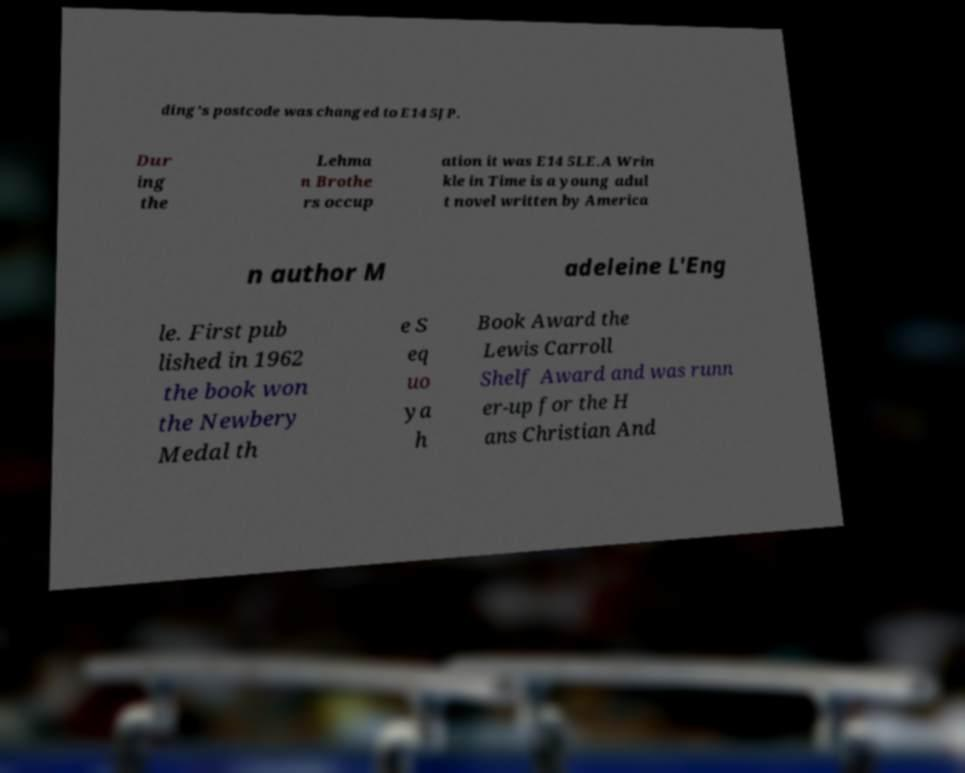Can you read and provide the text displayed in the image?This photo seems to have some interesting text. Can you extract and type it out for me? ding's postcode was changed to E14 5JP. Dur ing the Lehma n Brothe rs occup ation it was E14 5LE.A Wrin kle in Time is a young adul t novel written by America n author M adeleine L'Eng le. First pub lished in 1962 the book won the Newbery Medal th e S eq uo ya h Book Award the Lewis Carroll Shelf Award and was runn er-up for the H ans Christian And 